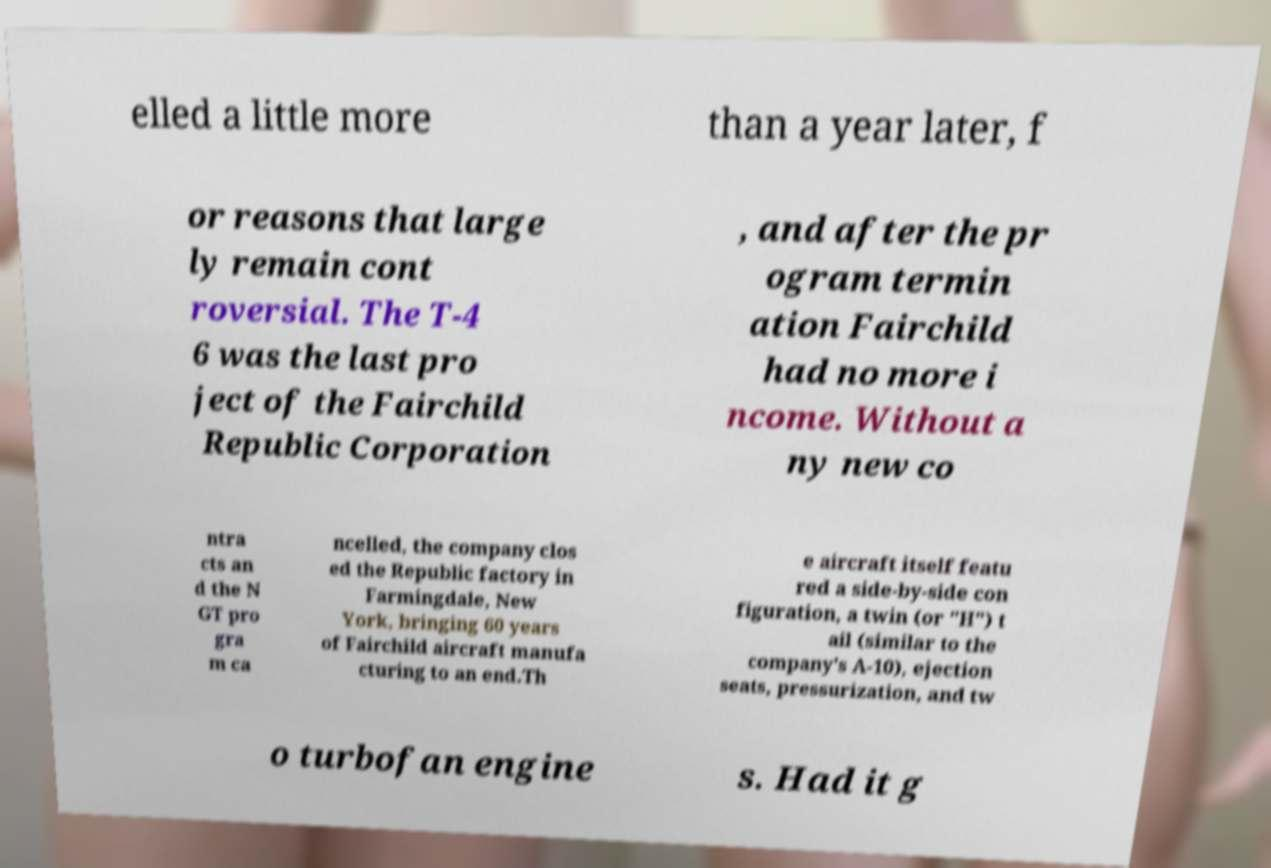Could you assist in decoding the text presented in this image and type it out clearly? elled a little more than a year later, f or reasons that large ly remain cont roversial. The T-4 6 was the last pro ject of the Fairchild Republic Corporation , and after the pr ogram termin ation Fairchild had no more i ncome. Without a ny new co ntra cts an d the N GT pro gra m ca ncelled, the company clos ed the Republic factory in Farmingdale, New York, bringing 60 years of Fairchild aircraft manufa cturing to an end.Th e aircraft itself featu red a side-by-side con figuration, a twin (or "H") t ail (similar to the company's A-10), ejection seats, pressurization, and tw o turbofan engine s. Had it g 